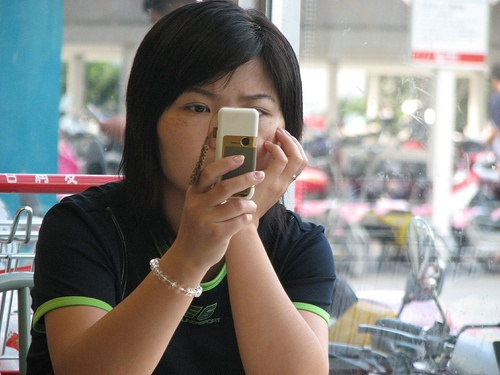Describe the objects in this image and their specific colors. I can see people in teal, black, maroon, gray, and tan tones, motorcycle in teal, darkgray, gray, and lightgray tones, bicycle in teal, darkgray, and lightgray tones, cell phone in teal, darkgray, gray, tan, and black tones, and chair in teal, gray, darkgray, black, and darkgreen tones in this image. 